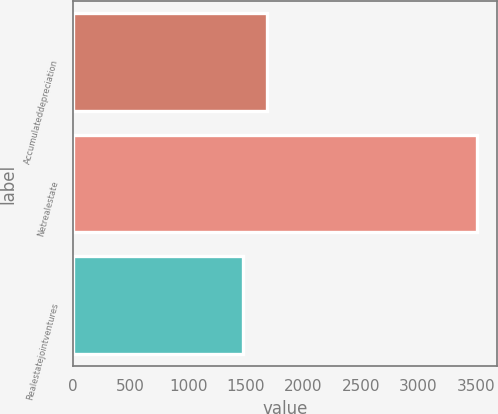<chart> <loc_0><loc_0><loc_500><loc_500><bar_chart><fcel>Accumulateddepreciation<fcel>Netrealestate<fcel>Realestatejointventures<nl><fcel>1680.2<fcel>3509<fcel>1477<nl></chart> 